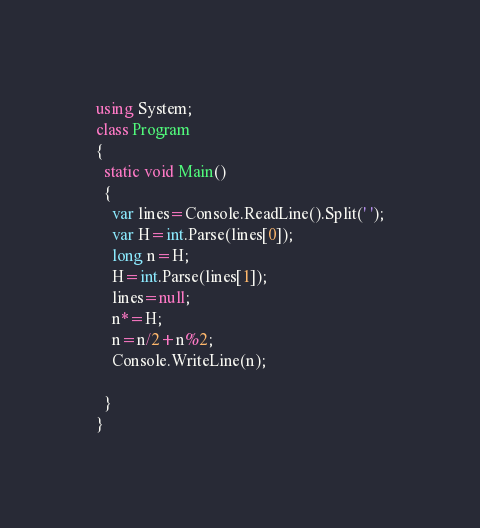Convert code to text. <code><loc_0><loc_0><loc_500><loc_500><_C#_>using System;
class Program
{
  static void Main()
  {
    var lines=Console.ReadLine().Split(' ');
    var H=int.Parse(lines[0]);
    long n=H;
    H=int.Parse(lines[1]);
    lines=null;
    n*=H;
    n=n/2+n%2;
    Console.WriteLine(n);
    
  }
}</code> 